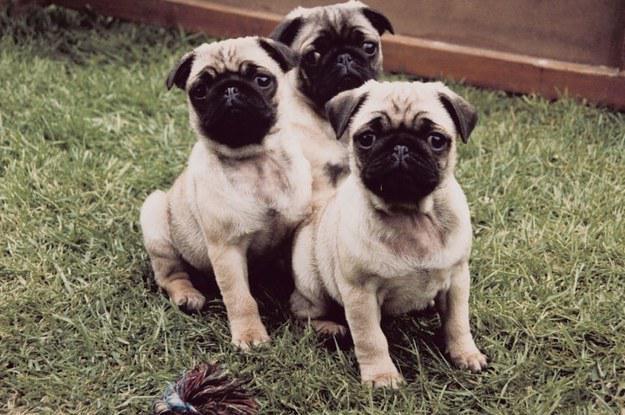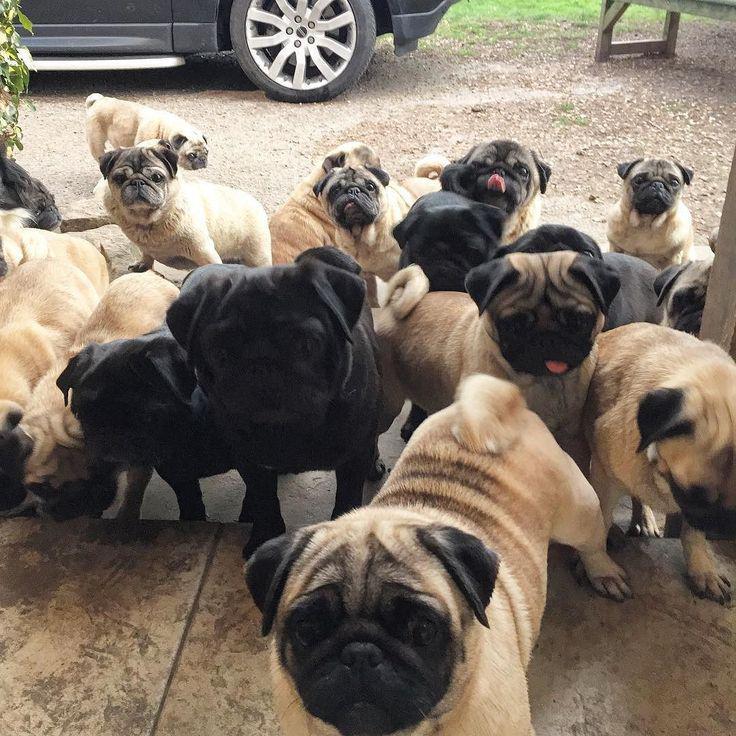The first image is the image on the left, the second image is the image on the right. Considering the images on both sides, is "A group of dogs is near a wooden fence in one of the images." valid? Answer yes or no. No. The first image is the image on the left, the second image is the image on the right. Analyze the images presented: Is the assertion "An image shows multiple pug dogs wearing harnesses." valid? Answer yes or no. No. 